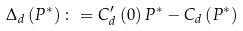<formula> <loc_0><loc_0><loc_500><loc_500>\Delta _ { d } \left ( P ^ { \ast } \right ) \colon = C _ { d } ^ { \prime } \left ( 0 \right ) P ^ { \ast } - C _ { d } \left ( P ^ { \ast } \right )</formula> 